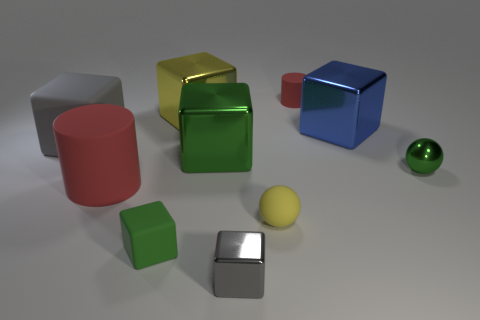There is a ball to the right of the tiny object that is behind the small green object right of the large blue cube; what size is it?
Offer a terse response. Small. Is the number of green cubes that are right of the gray metallic cube less than the number of small cylinders that are to the right of the big gray thing?
Give a very brief answer. Yes. What number of green balls have the same material as the large gray cube?
Your answer should be compact. 0. There is a red cylinder right of the yellow thing in front of the green shiny ball; is there a red cylinder that is behind it?
Keep it short and to the point. No. There is a large green thing that is made of the same material as the large yellow block; what is its shape?
Make the answer very short. Cube. Is the number of tiny cylinders greater than the number of cyan cylinders?
Offer a terse response. Yes. There is a big yellow thing; does it have the same shape as the green object in front of the large red cylinder?
Your answer should be compact. Yes. What material is the large blue cube?
Your answer should be very brief. Metal. There is a tiny rubber thing that is behind the large matte object to the right of the large block on the left side of the tiny rubber cube; what color is it?
Provide a succinct answer. Red. There is a yellow thing that is the same shape as the blue object; what is its material?
Provide a succinct answer. Metal. 